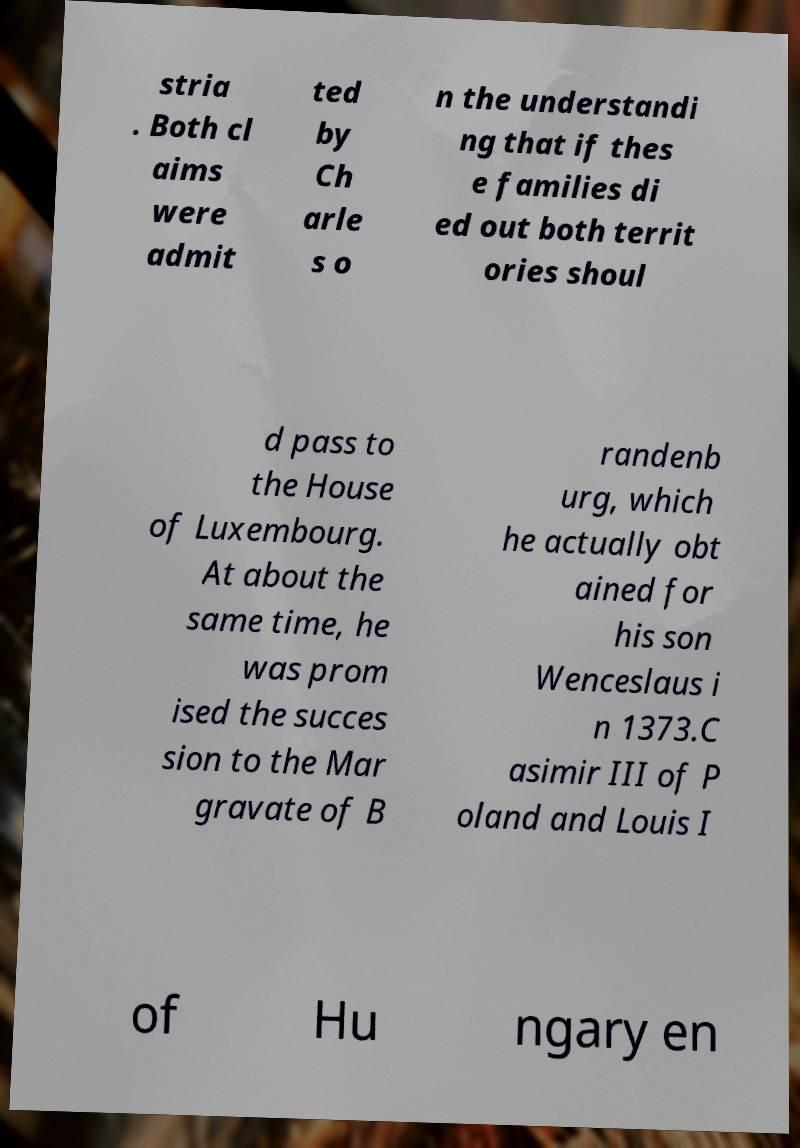Please read and relay the text visible in this image. What does it say? stria . Both cl aims were admit ted by Ch arle s o n the understandi ng that if thes e families di ed out both territ ories shoul d pass to the House of Luxembourg. At about the same time, he was prom ised the succes sion to the Mar gravate of B randenb urg, which he actually obt ained for his son Wenceslaus i n 1373.C asimir III of P oland and Louis I of Hu ngary en 